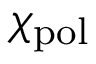<formula> <loc_0><loc_0><loc_500><loc_500>\chi _ { p o l }</formula> 